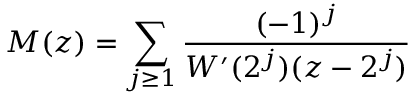Convert formula to latex. <formula><loc_0><loc_0><loc_500><loc_500>M ( z ) = \sum _ { j \geq 1 } { \frac { ( - 1 ) ^ { j } } { W ^ { \prime } ( 2 ^ { j } ) ( z - 2 ^ { j } ) } }</formula> 